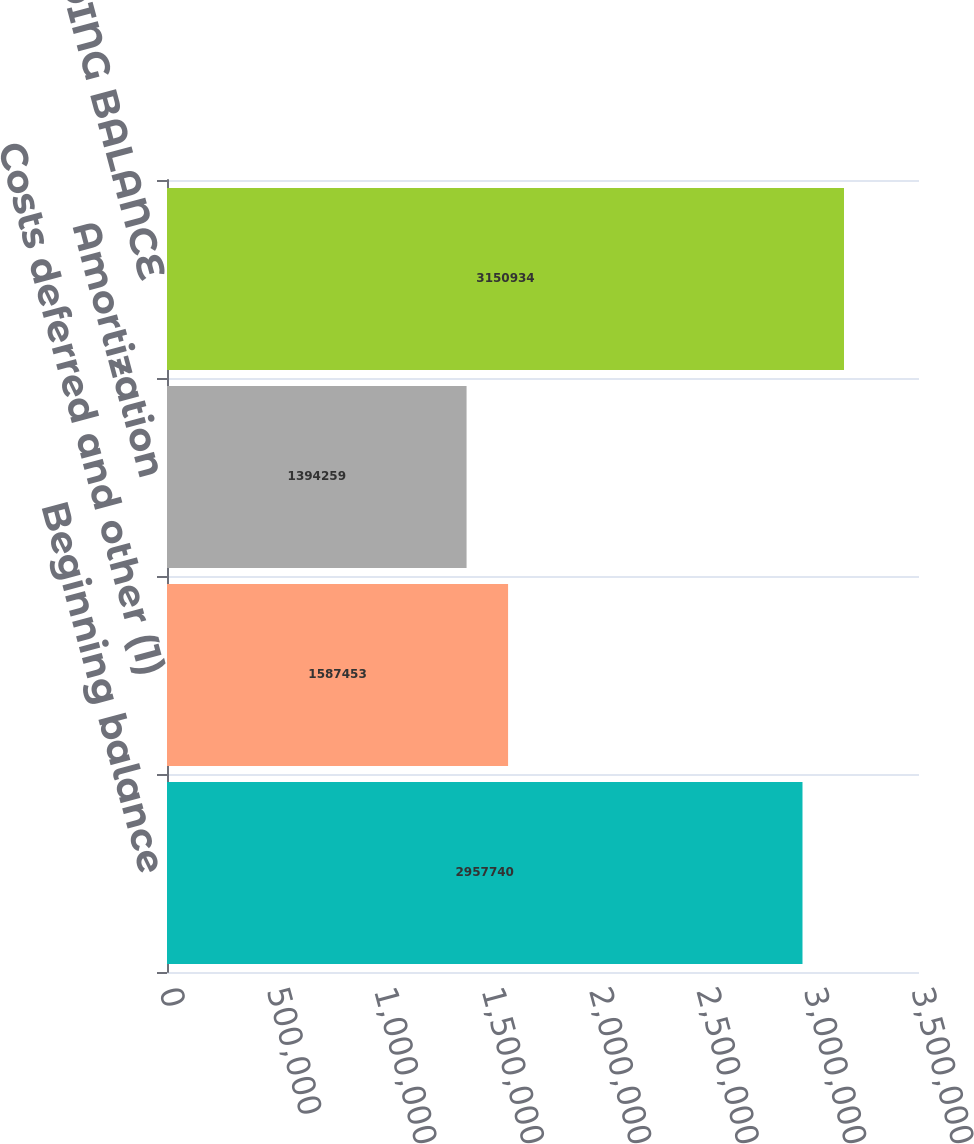Convert chart to OTSL. <chart><loc_0><loc_0><loc_500><loc_500><bar_chart><fcel>Beginning balance<fcel>Costs deferred and other (1)<fcel>Amortization<fcel>ENDING BALANCE<nl><fcel>2.95774e+06<fcel>1.58745e+06<fcel>1.39426e+06<fcel>3.15093e+06<nl></chart> 